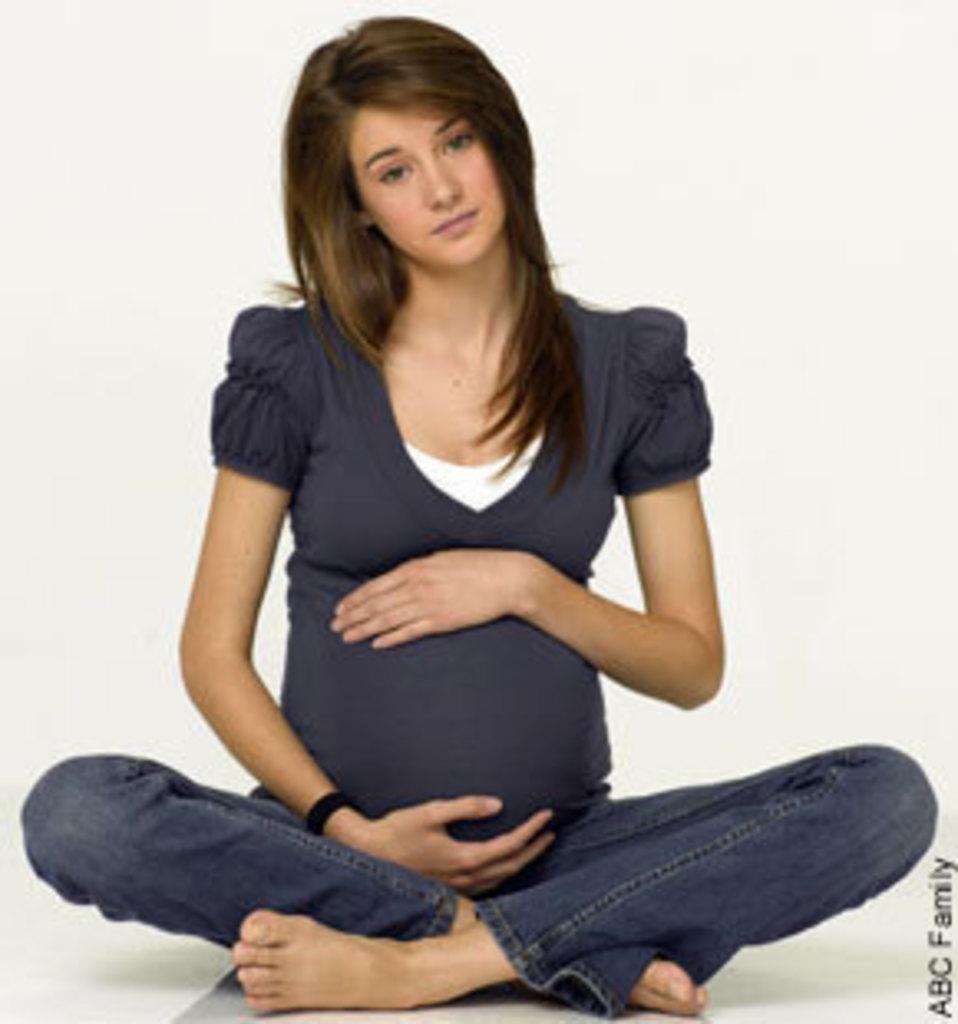Can you describe this image briefly? In this image we can see a pregnant lady sitting on the floor. In the background there is a wall. 